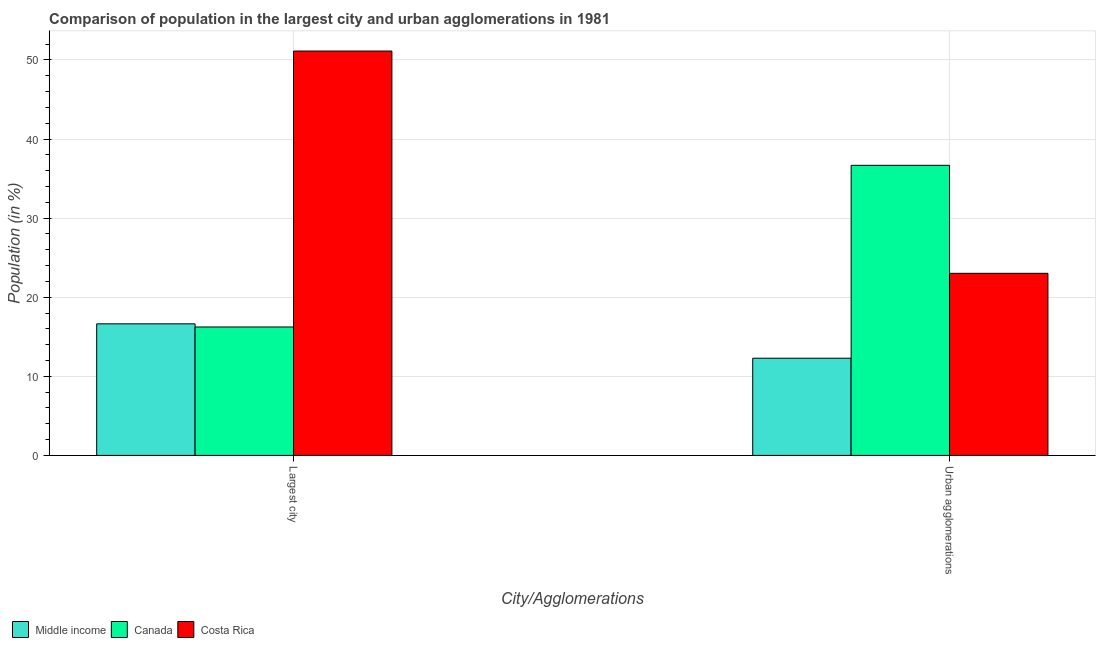How many different coloured bars are there?
Provide a short and direct response. 3. How many groups of bars are there?
Ensure brevity in your answer.  2. Are the number of bars on each tick of the X-axis equal?
Ensure brevity in your answer.  Yes. What is the label of the 1st group of bars from the left?
Your answer should be very brief. Largest city. What is the population in the largest city in Canada?
Provide a succinct answer. 16.24. Across all countries, what is the maximum population in the largest city?
Your answer should be compact. 51.13. Across all countries, what is the minimum population in urban agglomerations?
Keep it short and to the point. 12.29. In which country was the population in urban agglomerations maximum?
Your answer should be compact. Canada. In which country was the population in the largest city minimum?
Offer a terse response. Canada. What is the total population in the largest city in the graph?
Offer a terse response. 84. What is the difference between the population in urban agglomerations in Canada and that in Middle income?
Your response must be concise. 24.39. What is the difference between the population in urban agglomerations in Canada and the population in the largest city in Costa Rica?
Offer a terse response. -14.45. What is the average population in the largest city per country?
Your response must be concise. 28. What is the difference between the population in the largest city and population in urban agglomerations in Canada?
Provide a short and direct response. -20.44. In how many countries, is the population in the largest city greater than 50 %?
Keep it short and to the point. 1. What is the ratio of the population in urban agglomerations in Costa Rica to that in Canada?
Ensure brevity in your answer.  0.63. Is the population in the largest city in Middle income less than that in Costa Rica?
Make the answer very short. Yes. How many bars are there?
Ensure brevity in your answer.  6. Are the values on the major ticks of Y-axis written in scientific E-notation?
Your answer should be compact. No. Does the graph contain any zero values?
Provide a succinct answer. No. Does the graph contain grids?
Provide a short and direct response. Yes. How many legend labels are there?
Your answer should be compact. 3. What is the title of the graph?
Offer a very short reply. Comparison of population in the largest city and urban agglomerations in 1981. Does "World" appear as one of the legend labels in the graph?
Give a very brief answer. No. What is the label or title of the X-axis?
Make the answer very short. City/Agglomerations. What is the Population (in %) of Middle income in Largest city?
Provide a succinct answer. 16.64. What is the Population (in %) in Canada in Largest city?
Your response must be concise. 16.24. What is the Population (in %) in Costa Rica in Largest city?
Provide a short and direct response. 51.13. What is the Population (in %) in Middle income in Urban agglomerations?
Make the answer very short. 12.29. What is the Population (in %) of Canada in Urban agglomerations?
Offer a very short reply. 36.68. What is the Population (in %) of Costa Rica in Urban agglomerations?
Offer a terse response. 23.02. Across all City/Agglomerations, what is the maximum Population (in %) of Middle income?
Ensure brevity in your answer.  16.64. Across all City/Agglomerations, what is the maximum Population (in %) of Canada?
Your answer should be compact. 36.68. Across all City/Agglomerations, what is the maximum Population (in %) in Costa Rica?
Your answer should be compact. 51.13. Across all City/Agglomerations, what is the minimum Population (in %) of Middle income?
Your answer should be compact. 12.29. Across all City/Agglomerations, what is the minimum Population (in %) in Canada?
Provide a short and direct response. 16.24. Across all City/Agglomerations, what is the minimum Population (in %) in Costa Rica?
Your answer should be compact. 23.02. What is the total Population (in %) in Middle income in the graph?
Provide a short and direct response. 28.93. What is the total Population (in %) of Canada in the graph?
Your response must be concise. 52.92. What is the total Population (in %) of Costa Rica in the graph?
Your response must be concise. 74.15. What is the difference between the Population (in %) of Middle income in Largest city and that in Urban agglomerations?
Make the answer very short. 4.35. What is the difference between the Population (in %) of Canada in Largest city and that in Urban agglomerations?
Offer a terse response. -20.44. What is the difference between the Population (in %) in Costa Rica in Largest city and that in Urban agglomerations?
Your answer should be very brief. 28.1. What is the difference between the Population (in %) of Middle income in Largest city and the Population (in %) of Canada in Urban agglomerations?
Your answer should be compact. -20.04. What is the difference between the Population (in %) in Middle income in Largest city and the Population (in %) in Costa Rica in Urban agglomerations?
Give a very brief answer. -6.39. What is the difference between the Population (in %) in Canada in Largest city and the Population (in %) in Costa Rica in Urban agglomerations?
Your answer should be very brief. -6.78. What is the average Population (in %) in Middle income per City/Agglomerations?
Your response must be concise. 14.46. What is the average Population (in %) of Canada per City/Agglomerations?
Your response must be concise. 26.46. What is the average Population (in %) in Costa Rica per City/Agglomerations?
Ensure brevity in your answer.  37.08. What is the difference between the Population (in %) of Middle income and Population (in %) of Canada in Largest city?
Your answer should be very brief. 0.4. What is the difference between the Population (in %) in Middle income and Population (in %) in Costa Rica in Largest city?
Offer a terse response. -34.49. What is the difference between the Population (in %) of Canada and Population (in %) of Costa Rica in Largest city?
Provide a succinct answer. -34.89. What is the difference between the Population (in %) of Middle income and Population (in %) of Canada in Urban agglomerations?
Give a very brief answer. -24.39. What is the difference between the Population (in %) of Middle income and Population (in %) of Costa Rica in Urban agglomerations?
Give a very brief answer. -10.73. What is the difference between the Population (in %) of Canada and Population (in %) of Costa Rica in Urban agglomerations?
Offer a terse response. 13.65. What is the ratio of the Population (in %) in Middle income in Largest city to that in Urban agglomerations?
Offer a very short reply. 1.35. What is the ratio of the Population (in %) in Canada in Largest city to that in Urban agglomerations?
Your answer should be compact. 0.44. What is the ratio of the Population (in %) in Costa Rica in Largest city to that in Urban agglomerations?
Your answer should be compact. 2.22. What is the difference between the highest and the second highest Population (in %) of Middle income?
Offer a terse response. 4.35. What is the difference between the highest and the second highest Population (in %) of Canada?
Offer a very short reply. 20.44. What is the difference between the highest and the second highest Population (in %) of Costa Rica?
Your answer should be compact. 28.1. What is the difference between the highest and the lowest Population (in %) in Middle income?
Ensure brevity in your answer.  4.35. What is the difference between the highest and the lowest Population (in %) of Canada?
Offer a very short reply. 20.44. What is the difference between the highest and the lowest Population (in %) in Costa Rica?
Give a very brief answer. 28.1. 